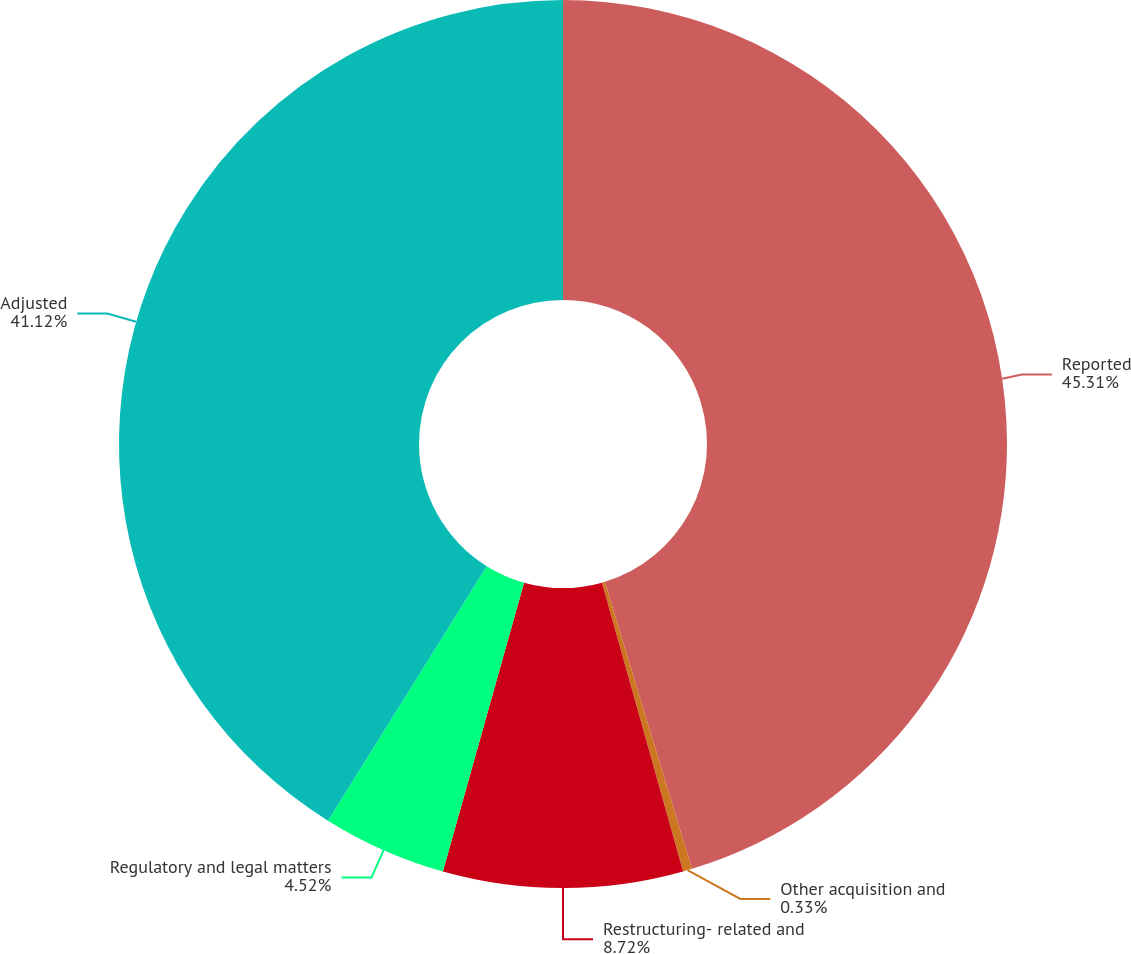<chart> <loc_0><loc_0><loc_500><loc_500><pie_chart><fcel>Reported<fcel>Other acquisition and<fcel>Restructuring- related and<fcel>Regulatory and legal matters<fcel>Adjusted<nl><fcel>45.31%<fcel>0.33%<fcel>8.72%<fcel>4.52%<fcel>41.12%<nl></chart> 